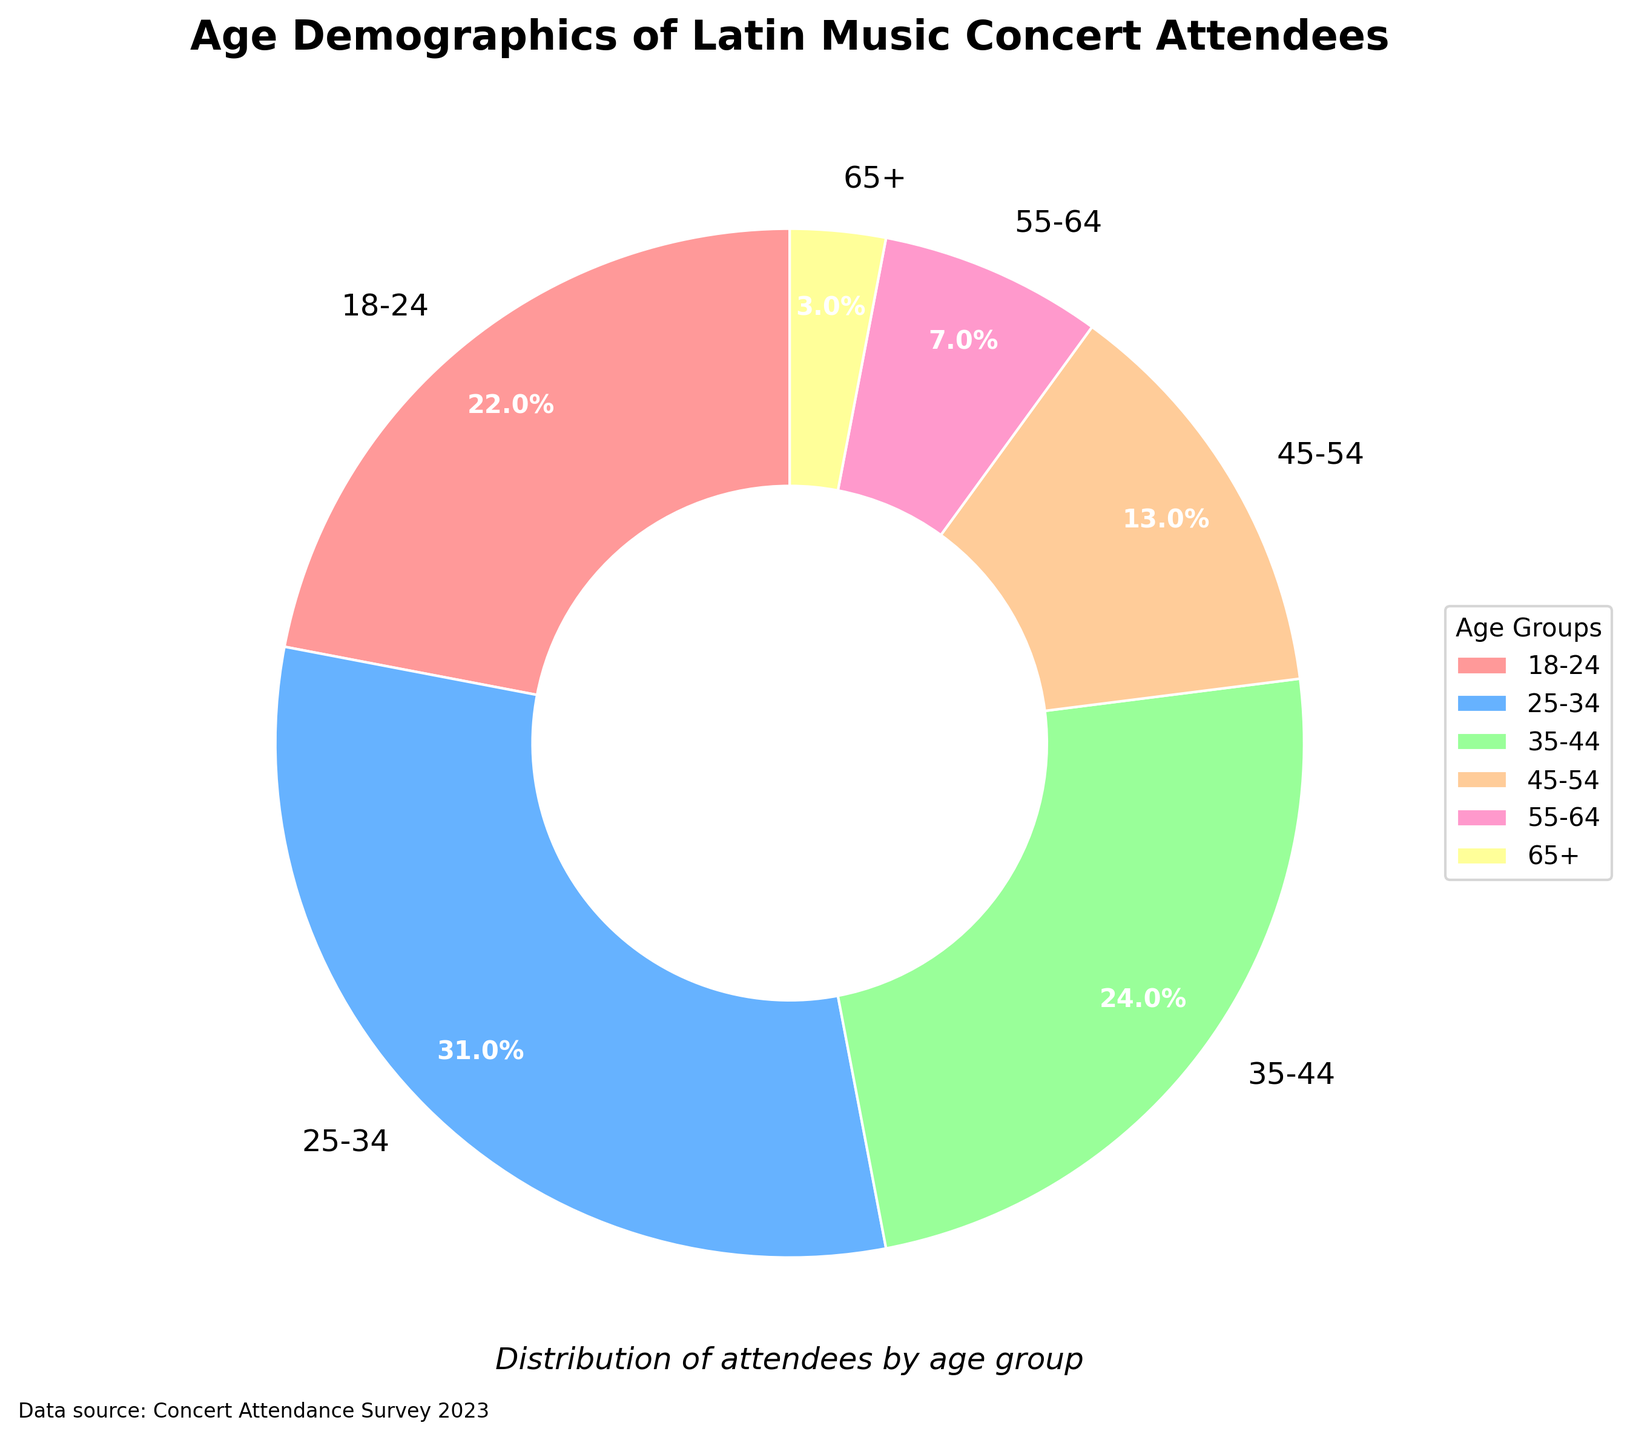What's the largest age group of Latin music concert attendees? Review the pie chart and find the age group with the largest percentage. The 25-34 age group contains the largest proportion at 31%.
Answer: 25-34 What's the combined percentage of attendees aged 35 to 54? Add the percentages of the 35-44 and 45-54 age groups. The sum is 24% (35-44) + 13% (45-54) = 37%.
Answer: 37% Which age group has the smallest proportion of attendees? Identify the smallest segment in the pie chart. The 65+ age group is the smallest at 3%.
Answer: 65+ How much higher is the percentage of the 25-34 age group compared to the 18-24 age group? Subtract the percentage of the 18-24 age group from the 25-34 age group. The difference is 31% (25-34) - 22% (18-24) = 9%.
Answer: 9% What is the sum of the percentages for the attendees under 35 years old? Combine the percentages of the 18-24 and 25-34 age groups. The total is 22% (18-24) + 31% (25-34) = 53%.
Answer: 53% How does the attendance of the 45-54 age group compare to that of the 55-64 age group? Compare the percentages directly. The 45-54 age group has 13% of attendees, while the 55-64 age group has 7%, making the 45-54 age group larger.
Answer: 45-54 > 55-64 What's the average percentage of all age groups represented in the pie chart? To find the average, add up all the percentages and divide by the number of age groups. Total percentage is 100%, and there are 6 groups. So, the average is 100% / 6 = 16.67% (rounded to two decimal places).
Answer: 16.67% Which age groups collectively make up more than half of the attendees? Add the percentages from the age groups sequentially until the sum exceeds 50%. 22% (18-24) + 31% (25-34) = 53%, which is just more than half.
Answer: 18-34 